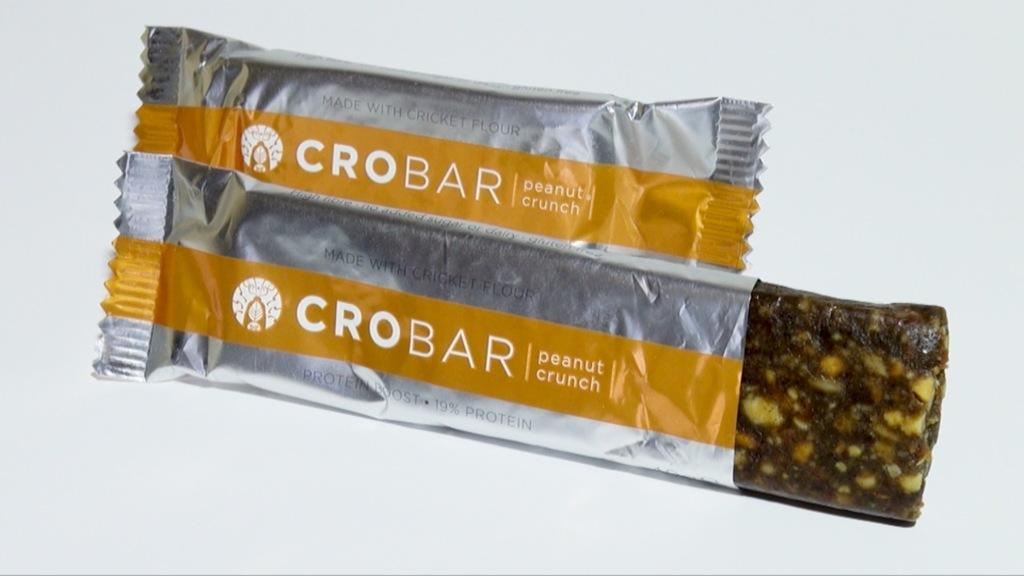What is the main subject of the image? The main subject of the image is a choco bar. Where is the choco bar located in the image? The choco bar is in the center of the image. What type of quiver is visible in the image? There is no quiver present in the image; it features a choco bar in the center. 